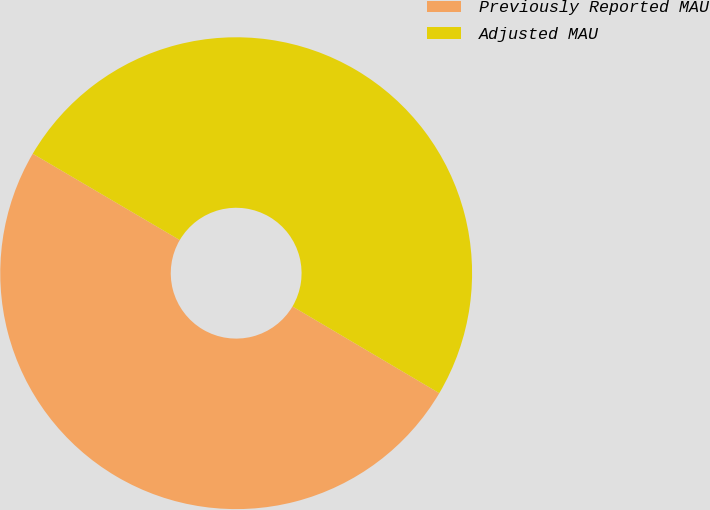<chart> <loc_0><loc_0><loc_500><loc_500><pie_chart><fcel>Previously Reported MAU<fcel>Adjusted MAU<nl><fcel>49.96%<fcel>50.04%<nl></chart> 